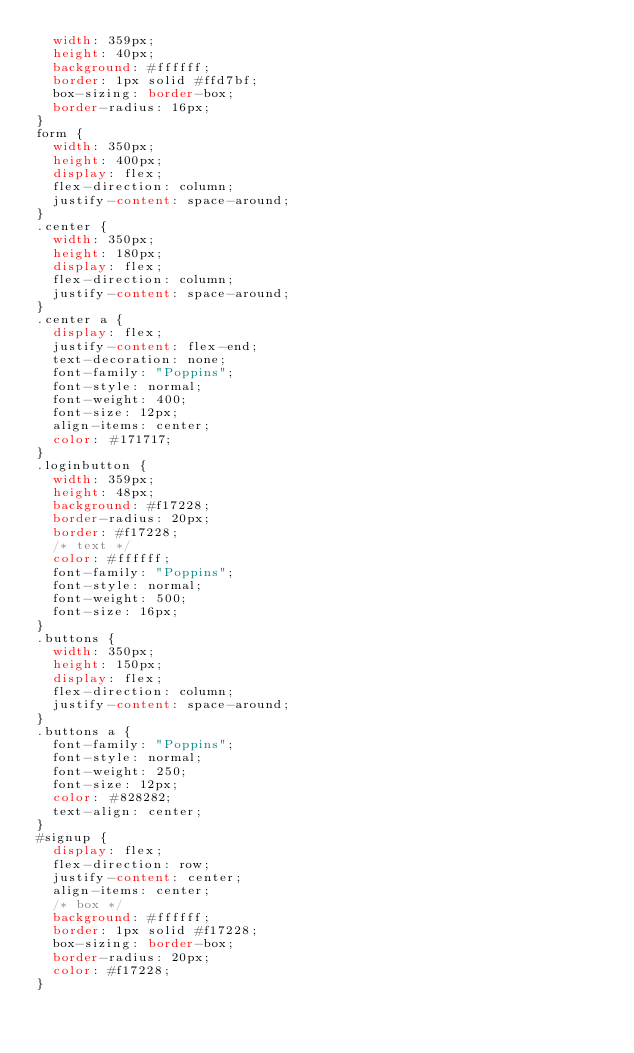<code> <loc_0><loc_0><loc_500><loc_500><_CSS_>  width: 359px;
  height: 40px;
  background: #ffffff;
  border: 1px solid #ffd7bf;
  box-sizing: border-box;
  border-radius: 16px;
}
form {
  width: 350px;
  height: 400px;
  display: flex;
  flex-direction: column;
  justify-content: space-around;
}
.center {
  width: 350px;
  height: 180px;
  display: flex;
  flex-direction: column;
  justify-content: space-around;
}
.center a {
  display: flex;
  justify-content: flex-end;
  text-decoration: none;
  font-family: "Poppins";
  font-style: normal;
  font-weight: 400;
  font-size: 12px;
  align-items: center;
  color: #171717;
}
.loginbutton {
  width: 359px;
  height: 48px;
  background: #f17228;
  border-radius: 20px;
  border: #f17228;
  /* text */
  color: #ffffff;
  font-family: "Poppins";
  font-style: normal;
  font-weight: 500;
  font-size: 16px;
}
.buttons {
  width: 350px;
  height: 150px;
  display: flex;
  flex-direction: column;
  justify-content: space-around;
}
.buttons a {
  font-family: "Poppins";
  font-style: normal;
  font-weight: 250;
  font-size: 12px;
  color: #828282;
  text-align: center;
}
#signup {
  display: flex;
  flex-direction: row;
  justify-content: center;
  align-items: center;
  /* box */
  background: #ffffff;
  border: 1px solid #f17228;
  box-sizing: border-box;
  border-radius: 20px;
  color: #f17228;
}
</code> 